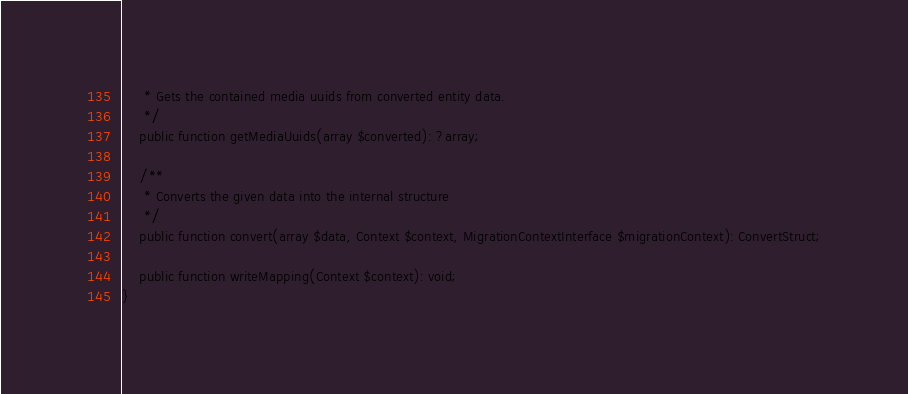Convert code to text. <code><loc_0><loc_0><loc_500><loc_500><_PHP_>     * Gets the contained media uuids from converted entity data.
     */
    public function getMediaUuids(array $converted): ?array;

    /**
     * Converts the given data into the internal structure
     */
    public function convert(array $data, Context $context, MigrationContextInterface $migrationContext): ConvertStruct;

    public function writeMapping(Context $context): void;
}
</code> 